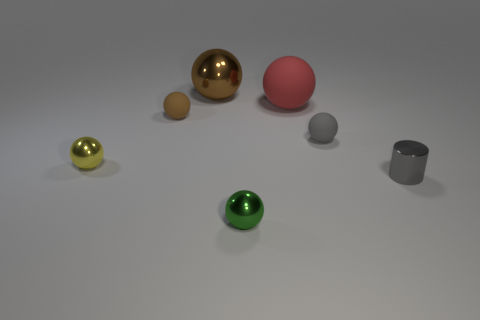Are there any yellow balls of the same size as the cylinder?
Keep it short and to the point. Yes. There is a yellow sphere that is the same size as the gray matte sphere; what is its material?
Give a very brief answer. Metal. There is a green metallic thing; is its size the same as the rubber thing on the left side of the green metal ball?
Keep it short and to the point. Yes. What material is the small gray object that is in front of the gray rubber sphere?
Provide a succinct answer. Metal. Are there the same number of large rubber objects that are in front of the metal cylinder and red rubber balls?
Give a very brief answer. No. Does the gray shiny cylinder have the same size as the gray sphere?
Ensure brevity in your answer.  Yes. Is there a yellow metal object to the left of the small rubber sphere that is on the left side of the gray thing behind the tiny yellow ball?
Offer a terse response. Yes. There is a small yellow thing that is the same shape as the green metal thing; what is it made of?
Your response must be concise. Metal. How many yellow shiny balls are left of the brown object that is in front of the big brown metallic object?
Give a very brief answer. 1. How big is the shiny ball that is to the right of the brown thing behind the rubber object left of the red matte sphere?
Provide a succinct answer. Small. 